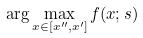<formula> <loc_0><loc_0><loc_500><loc_500>\arg \max _ { x \in [ x ^ { \prime \prime } , x ^ { \prime } ] } f ( x ; s )</formula> 